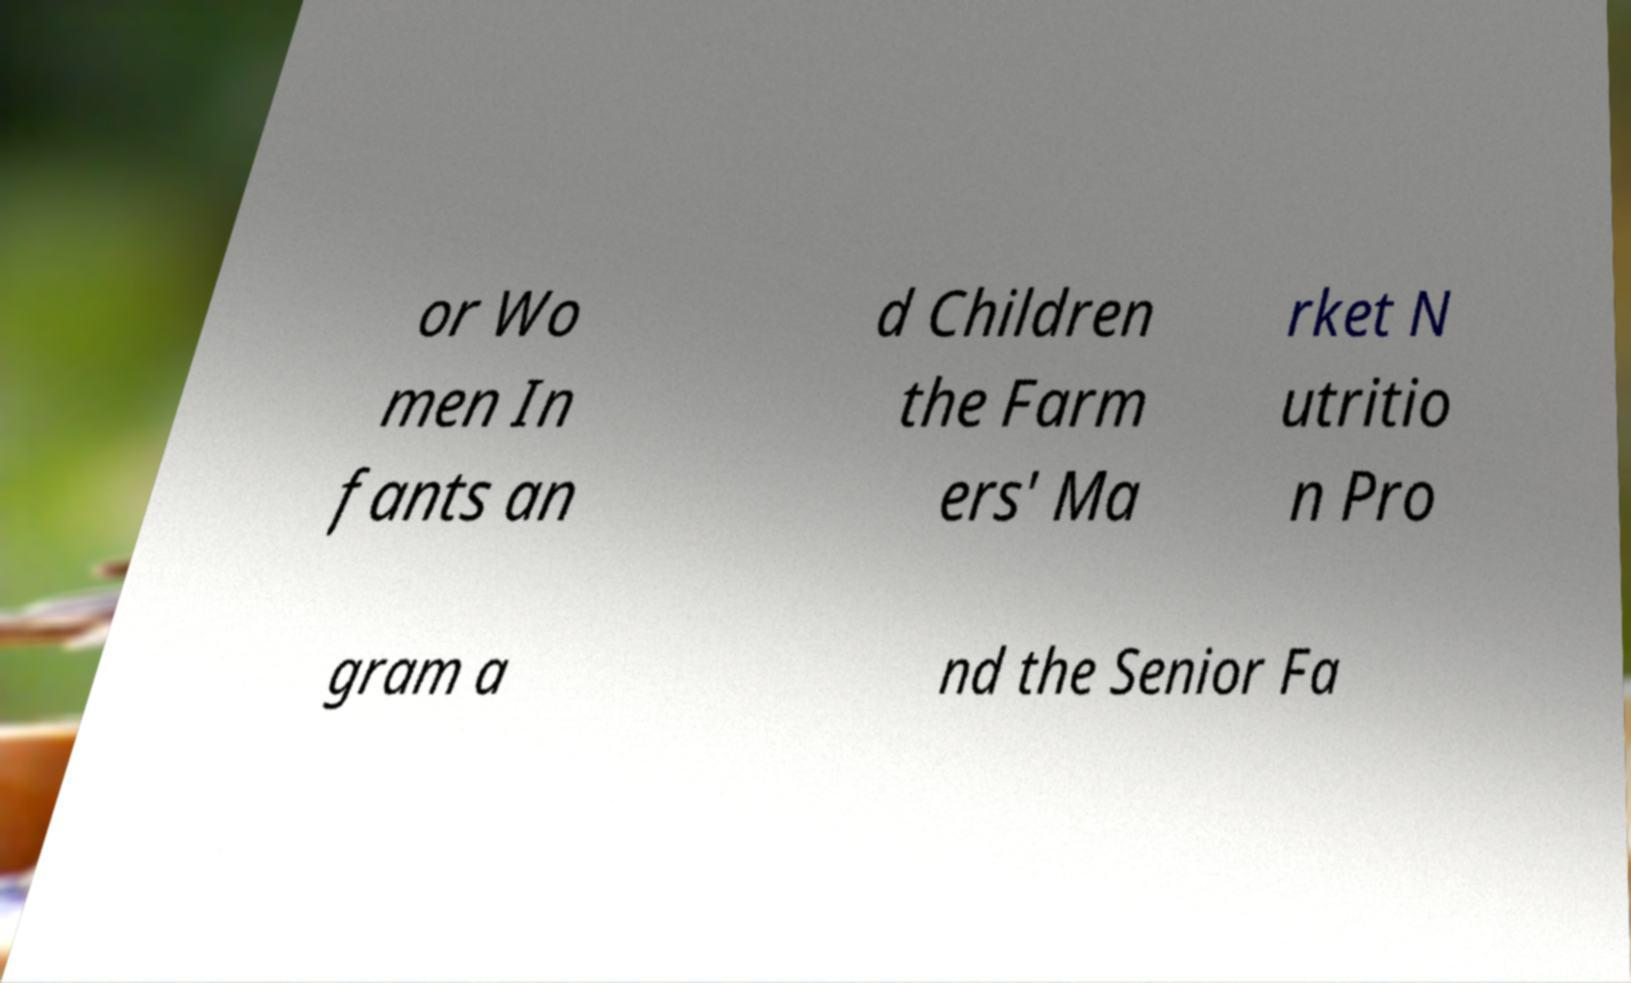Could you assist in decoding the text presented in this image and type it out clearly? or Wo men In fants an d Children the Farm ers' Ma rket N utritio n Pro gram a nd the Senior Fa 